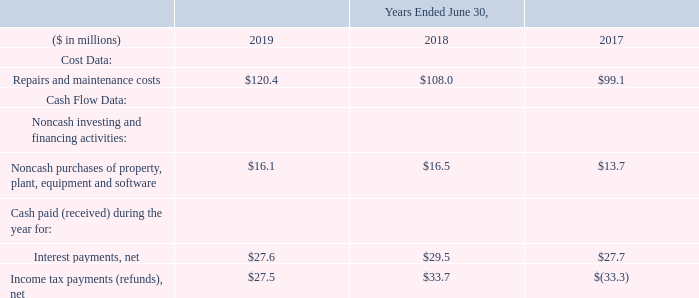21. Supplemental Data
The following are additional required disclosures and other material items:
What was the Repairs and maintenance costs in 2019?
Answer scale should be: million. $120.4. What was the  Noncash purchases of property, plant, equipment and software costs in 2018?
Answer scale should be: million. $16.5. In which years was the supplemental data provided? 2019, 2018, 2017. In which year was Repairs and maintenance costs the largest? 120.4>108.0>99.1
Answer: 2019. What was the change in Repairs and maintenance costs in 2019 from 2018?
Answer scale should be: million. 120.4-108.0
Answer: 12.4. What was the percentage change in Repairs and maintenance costs in 2019 from 2018?
Answer scale should be: percent. (120.4-108.0)/108.0
Answer: 11.48. 